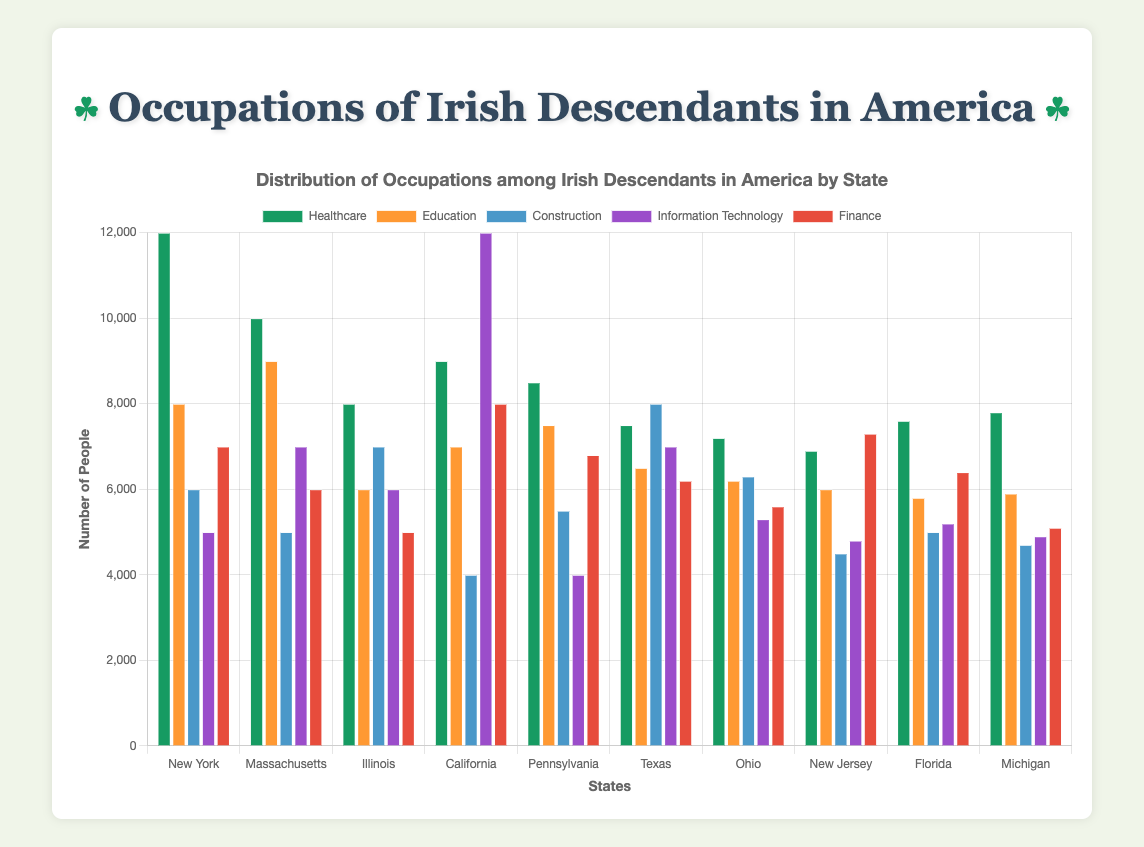Which state has the highest number of Irish descendants working in Healthcare? The bar representing Healthcare in New York is the highest among all states for this occupation.
Answer: New York In which state are Irish descendants least likely to work in Construction? The Construction bar for California is the shortest among all states for this occupation.
Answer: California Compare the number of Irish descendants working in Education in Massachusetts and New Jersey. Which state has more? The bar for Education in Massachusetts is taller than the bar for Education in New Jersey.
Answer: Massachusetts What is the total number of Irish descendants working in Information Technology across California and Texas? The Information Technology bar for California shows 12,000 and Texas shows 7,000. Summing these gives: 12,000 + 7,000 = 19,000.
Answer: 19,000 How does the number of Irish descendants working in Finance in Florida compare to those in Education in Florida? The bar for Finance in Florida shows 6,400 and the bar for Education in Florida shows 5,800. The Finance number is higher.
Answer: Finance Among the states New York, Ohio, and Michigan, which state has the most Irish descendants working in Information Technology? The bar for Information Technology in New York, Ohio, and Michigan reveals that New York has 5,000, Ohio has 5,300, and Michigan has 4,900. Ohio has the highest.
Answer: Ohio What is the difference in the number of Irish descendants working in Healthcare between New York and Illinois? The Healthcare bar for New York shows 12,000 and for Illinois shows 8,000. The difference is 12,000 - 8,000 = 4,000.
Answer: 4,000 In which state do Irish descendants have the highest employment in Information Technology? The tallest bar for Information Technology is in California with 12,000.
Answer: California Compare the total number of Irish descendants working in Finance in Ohio and New Jersey. Which state has more? The bar for Finance in Ohio shows 5,600 and in New Jersey shows 7,300. New Jersey has more.
Answer: New Jersey What is the average number of Irish descendants working in Healthcare across all states? Sum up the Healthcare numbers from each state (12,000 + 10,000 + 8,000 + 9,000 + 8,500 + 7,500 + 7,200 + 6,900 + 7,600 + 7,800) = 84,500. Then divide by the number of states: 84,500 / 10 = 8,450.
Answer: 8,450 